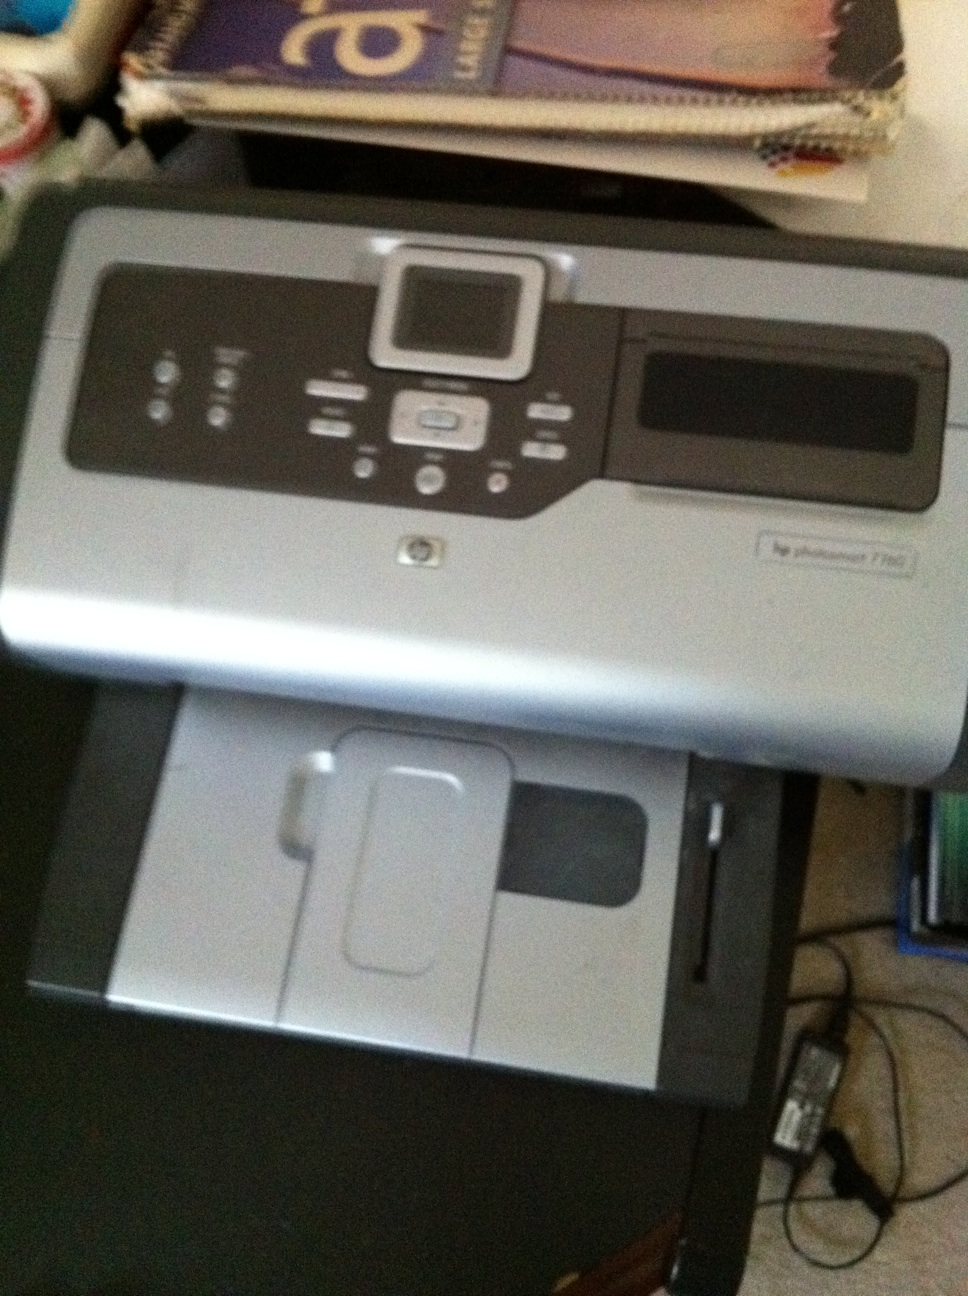What kind of connection ports does this printer have? The HP Photosmart 7280 comes with several connection options including USB 2.0, Ethernet, and PictBridge for direct printing from compatible cameras. It also features a memory card slot for direct photo printing. 